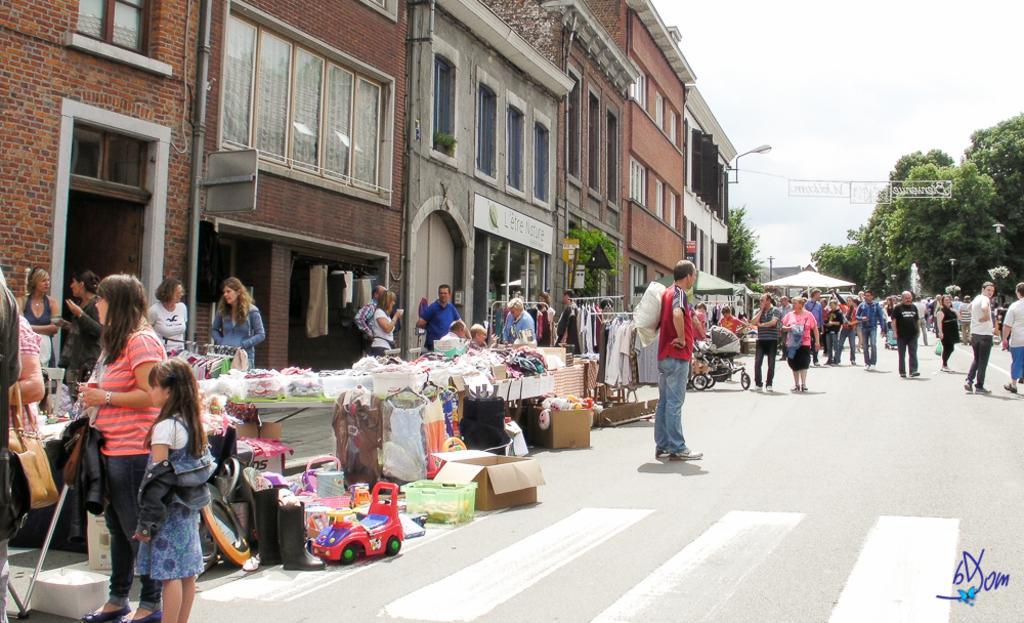Could you give a brief overview of what you see in this image? In this picture we can see the buildings, windows, light, poles, wall, doors, plants, tables, tents, clothes, trolley, boxes, containers, shoes, toys. On the tables we can see some objects. In the background of the image we can see the trees, poles, a group of people, boards. At the top of the image we can see the sky. At the bottom of the image we can see the road. In the bottom right corner we can see the text. 